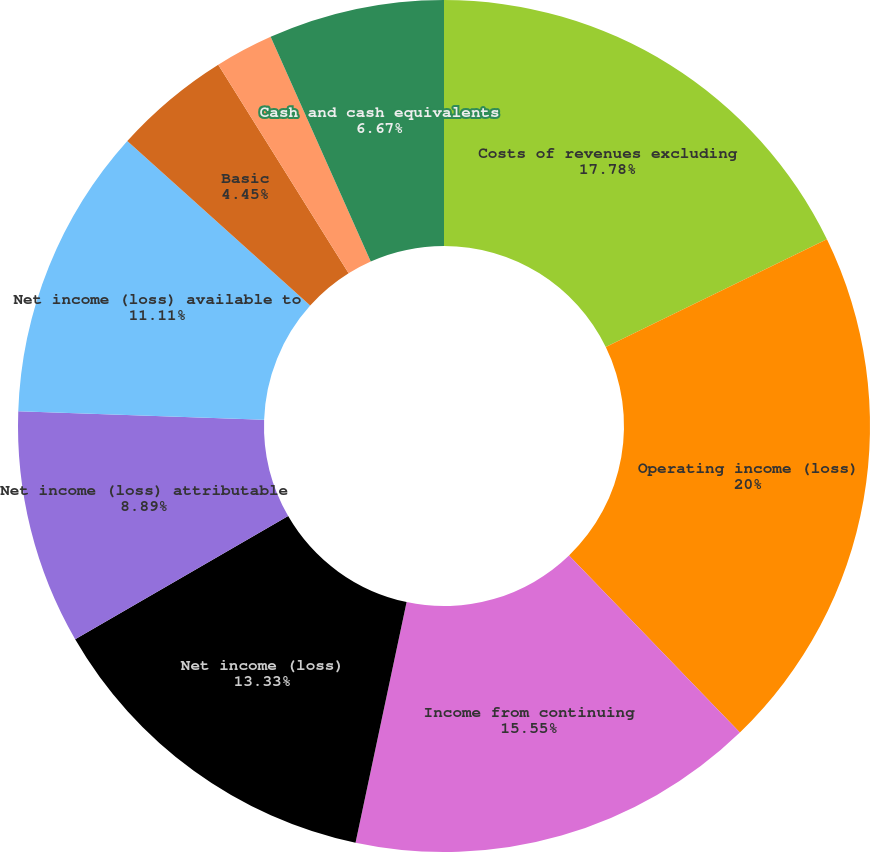Convert chart. <chart><loc_0><loc_0><loc_500><loc_500><pie_chart><fcel>Costs of revenues excluding<fcel>Operating income (loss)<fcel>Income from continuing<fcel>(Loss) income from<fcel>Net income (loss)<fcel>Net income (loss) attributable<fcel>Net income (loss) available to<fcel>Basic<fcel>Diluted<fcel>Cash and cash equivalents<nl><fcel>17.78%<fcel>20.0%<fcel>15.55%<fcel>0.0%<fcel>13.33%<fcel>8.89%<fcel>11.11%<fcel>4.45%<fcel>2.22%<fcel>6.67%<nl></chart> 